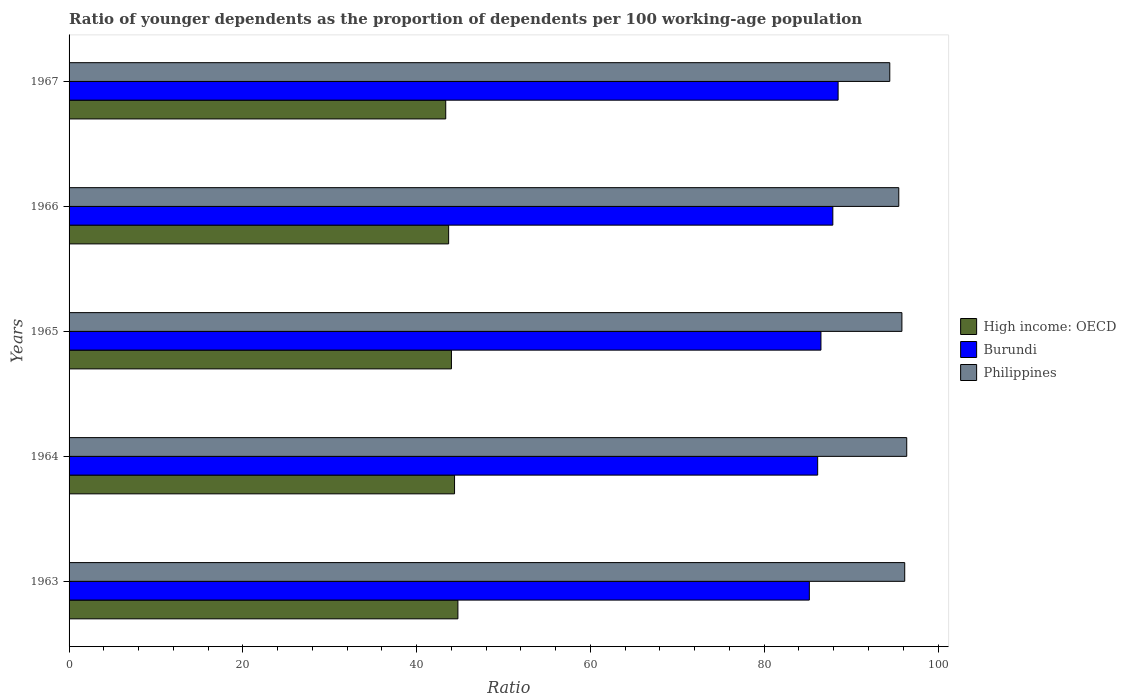Are the number of bars per tick equal to the number of legend labels?
Ensure brevity in your answer.  Yes. Are the number of bars on each tick of the Y-axis equal?
Ensure brevity in your answer.  Yes. How many bars are there on the 3rd tick from the top?
Your answer should be compact. 3. How many bars are there on the 2nd tick from the bottom?
Offer a very short reply. 3. In how many cases, is the number of bars for a given year not equal to the number of legend labels?
Your response must be concise. 0. What is the age dependency ratio(young) in Philippines in 1963?
Provide a succinct answer. 96.17. Across all years, what is the maximum age dependency ratio(young) in Philippines?
Your answer should be very brief. 96.4. Across all years, what is the minimum age dependency ratio(young) in High income: OECD?
Your answer should be compact. 43.35. In which year was the age dependency ratio(young) in Philippines minimum?
Your answer should be compact. 1967. What is the total age dependency ratio(young) in High income: OECD in the graph?
Ensure brevity in your answer.  220.14. What is the difference between the age dependency ratio(young) in Burundi in 1963 and that in 1965?
Make the answer very short. -1.34. What is the difference between the age dependency ratio(young) in High income: OECD in 1967 and the age dependency ratio(young) in Burundi in 1963?
Your response must be concise. -41.84. What is the average age dependency ratio(young) in Philippines per year?
Your answer should be compact. 95.67. In the year 1967, what is the difference between the age dependency ratio(young) in High income: OECD and age dependency ratio(young) in Philippines?
Make the answer very short. -51.1. In how many years, is the age dependency ratio(young) in High income: OECD greater than 60 ?
Your answer should be compact. 0. What is the ratio of the age dependency ratio(young) in Burundi in 1965 to that in 1967?
Offer a very short reply. 0.98. Is the age dependency ratio(young) in High income: OECD in 1965 less than that in 1967?
Keep it short and to the point. No. What is the difference between the highest and the second highest age dependency ratio(young) in High income: OECD?
Offer a terse response. 0.39. What is the difference between the highest and the lowest age dependency ratio(young) in High income: OECD?
Offer a very short reply. 1.4. What does the 3rd bar from the top in 1963 represents?
Provide a short and direct response. High income: OECD. What does the 3rd bar from the bottom in 1965 represents?
Offer a terse response. Philippines. What is the difference between two consecutive major ticks on the X-axis?
Provide a short and direct response. 20. Does the graph contain any zero values?
Provide a short and direct response. No. How many legend labels are there?
Your answer should be very brief. 3. What is the title of the graph?
Provide a short and direct response. Ratio of younger dependents as the proportion of dependents per 100 working-age population. Does "Cabo Verde" appear as one of the legend labels in the graph?
Provide a short and direct response. No. What is the label or title of the X-axis?
Your response must be concise. Ratio. What is the Ratio of High income: OECD in 1963?
Provide a succinct answer. 44.75. What is the Ratio in Burundi in 1963?
Provide a succinct answer. 85.19. What is the Ratio in Philippines in 1963?
Provide a short and direct response. 96.17. What is the Ratio in High income: OECD in 1964?
Make the answer very short. 44.36. What is the Ratio in Burundi in 1964?
Ensure brevity in your answer.  86.15. What is the Ratio of Philippines in 1964?
Ensure brevity in your answer.  96.4. What is the Ratio of High income: OECD in 1965?
Offer a terse response. 44. What is the Ratio of Burundi in 1965?
Your response must be concise. 86.53. What is the Ratio of Philippines in 1965?
Your answer should be compact. 95.85. What is the Ratio of High income: OECD in 1966?
Provide a short and direct response. 43.68. What is the Ratio of Burundi in 1966?
Provide a succinct answer. 87.9. What is the Ratio of Philippines in 1966?
Give a very brief answer. 95.49. What is the Ratio of High income: OECD in 1967?
Give a very brief answer. 43.35. What is the Ratio in Burundi in 1967?
Offer a terse response. 88.5. What is the Ratio of Philippines in 1967?
Offer a terse response. 94.45. Across all years, what is the maximum Ratio of High income: OECD?
Your answer should be very brief. 44.75. Across all years, what is the maximum Ratio of Burundi?
Give a very brief answer. 88.5. Across all years, what is the maximum Ratio of Philippines?
Offer a very short reply. 96.4. Across all years, what is the minimum Ratio in High income: OECD?
Provide a succinct answer. 43.35. Across all years, what is the minimum Ratio in Burundi?
Your response must be concise. 85.19. Across all years, what is the minimum Ratio in Philippines?
Offer a very short reply. 94.45. What is the total Ratio in High income: OECD in the graph?
Give a very brief answer. 220.14. What is the total Ratio of Burundi in the graph?
Your answer should be compact. 434.28. What is the total Ratio in Philippines in the graph?
Offer a very short reply. 478.36. What is the difference between the Ratio in High income: OECD in 1963 and that in 1964?
Your answer should be compact. 0.39. What is the difference between the Ratio of Burundi in 1963 and that in 1964?
Your answer should be compact. -0.96. What is the difference between the Ratio in Philippines in 1963 and that in 1964?
Ensure brevity in your answer.  -0.23. What is the difference between the Ratio in High income: OECD in 1963 and that in 1965?
Give a very brief answer. 0.74. What is the difference between the Ratio of Burundi in 1963 and that in 1965?
Provide a succinct answer. -1.34. What is the difference between the Ratio of Philippines in 1963 and that in 1965?
Provide a short and direct response. 0.32. What is the difference between the Ratio of High income: OECD in 1963 and that in 1966?
Your response must be concise. 1.07. What is the difference between the Ratio in Burundi in 1963 and that in 1966?
Your response must be concise. -2.7. What is the difference between the Ratio of Philippines in 1963 and that in 1966?
Give a very brief answer. 0.68. What is the difference between the Ratio in High income: OECD in 1963 and that in 1967?
Offer a terse response. 1.4. What is the difference between the Ratio in Burundi in 1963 and that in 1967?
Provide a short and direct response. -3.31. What is the difference between the Ratio of Philippines in 1963 and that in 1967?
Your answer should be compact. 1.72. What is the difference between the Ratio in High income: OECD in 1964 and that in 1965?
Your answer should be compact. 0.36. What is the difference between the Ratio of Burundi in 1964 and that in 1965?
Provide a succinct answer. -0.38. What is the difference between the Ratio of Philippines in 1964 and that in 1965?
Offer a terse response. 0.56. What is the difference between the Ratio of High income: OECD in 1964 and that in 1966?
Provide a short and direct response. 0.68. What is the difference between the Ratio in Burundi in 1964 and that in 1966?
Your response must be concise. -1.74. What is the difference between the Ratio of Philippines in 1964 and that in 1966?
Offer a very short reply. 0.91. What is the difference between the Ratio in High income: OECD in 1964 and that in 1967?
Keep it short and to the point. 1.01. What is the difference between the Ratio in Burundi in 1964 and that in 1967?
Offer a very short reply. -2.35. What is the difference between the Ratio in Philippines in 1964 and that in 1967?
Offer a very short reply. 1.95. What is the difference between the Ratio of High income: OECD in 1965 and that in 1966?
Your answer should be very brief. 0.32. What is the difference between the Ratio of Burundi in 1965 and that in 1966?
Your answer should be very brief. -1.37. What is the difference between the Ratio of Philippines in 1965 and that in 1966?
Your response must be concise. 0.36. What is the difference between the Ratio in High income: OECD in 1965 and that in 1967?
Provide a succinct answer. 0.65. What is the difference between the Ratio in Burundi in 1965 and that in 1967?
Offer a very short reply. -1.97. What is the difference between the Ratio of Philippines in 1965 and that in 1967?
Provide a short and direct response. 1.4. What is the difference between the Ratio of High income: OECD in 1966 and that in 1967?
Your response must be concise. 0.33. What is the difference between the Ratio of Burundi in 1966 and that in 1967?
Give a very brief answer. -0.61. What is the difference between the Ratio in High income: OECD in 1963 and the Ratio in Burundi in 1964?
Ensure brevity in your answer.  -41.4. What is the difference between the Ratio of High income: OECD in 1963 and the Ratio of Philippines in 1964?
Ensure brevity in your answer.  -51.65. What is the difference between the Ratio in Burundi in 1963 and the Ratio in Philippines in 1964?
Provide a short and direct response. -11.21. What is the difference between the Ratio in High income: OECD in 1963 and the Ratio in Burundi in 1965?
Provide a succinct answer. -41.78. What is the difference between the Ratio of High income: OECD in 1963 and the Ratio of Philippines in 1965?
Ensure brevity in your answer.  -51.1. What is the difference between the Ratio of Burundi in 1963 and the Ratio of Philippines in 1965?
Ensure brevity in your answer.  -10.65. What is the difference between the Ratio in High income: OECD in 1963 and the Ratio in Burundi in 1966?
Offer a terse response. -43.15. What is the difference between the Ratio in High income: OECD in 1963 and the Ratio in Philippines in 1966?
Keep it short and to the point. -50.74. What is the difference between the Ratio of Burundi in 1963 and the Ratio of Philippines in 1966?
Provide a succinct answer. -10.29. What is the difference between the Ratio in High income: OECD in 1963 and the Ratio in Burundi in 1967?
Keep it short and to the point. -43.76. What is the difference between the Ratio of High income: OECD in 1963 and the Ratio of Philippines in 1967?
Offer a terse response. -49.7. What is the difference between the Ratio of Burundi in 1963 and the Ratio of Philippines in 1967?
Make the answer very short. -9.26. What is the difference between the Ratio in High income: OECD in 1964 and the Ratio in Burundi in 1965?
Give a very brief answer. -42.17. What is the difference between the Ratio of High income: OECD in 1964 and the Ratio of Philippines in 1965?
Provide a short and direct response. -51.48. What is the difference between the Ratio of Burundi in 1964 and the Ratio of Philippines in 1965?
Offer a very short reply. -9.69. What is the difference between the Ratio of High income: OECD in 1964 and the Ratio of Burundi in 1966?
Provide a succinct answer. -43.53. What is the difference between the Ratio in High income: OECD in 1964 and the Ratio in Philippines in 1966?
Make the answer very short. -51.13. What is the difference between the Ratio of Burundi in 1964 and the Ratio of Philippines in 1966?
Your answer should be compact. -9.33. What is the difference between the Ratio of High income: OECD in 1964 and the Ratio of Burundi in 1967?
Your response must be concise. -44.14. What is the difference between the Ratio of High income: OECD in 1964 and the Ratio of Philippines in 1967?
Your answer should be compact. -50.09. What is the difference between the Ratio in Burundi in 1964 and the Ratio in Philippines in 1967?
Offer a very short reply. -8.3. What is the difference between the Ratio in High income: OECD in 1965 and the Ratio in Burundi in 1966?
Make the answer very short. -43.89. What is the difference between the Ratio of High income: OECD in 1965 and the Ratio of Philippines in 1966?
Give a very brief answer. -51.48. What is the difference between the Ratio in Burundi in 1965 and the Ratio in Philippines in 1966?
Your answer should be very brief. -8.96. What is the difference between the Ratio of High income: OECD in 1965 and the Ratio of Burundi in 1967?
Give a very brief answer. -44.5. What is the difference between the Ratio in High income: OECD in 1965 and the Ratio in Philippines in 1967?
Provide a succinct answer. -50.45. What is the difference between the Ratio in Burundi in 1965 and the Ratio in Philippines in 1967?
Ensure brevity in your answer.  -7.92. What is the difference between the Ratio in High income: OECD in 1966 and the Ratio in Burundi in 1967?
Ensure brevity in your answer.  -44.82. What is the difference between the Ratio in High income: OECD in 1966 and the Ratio in Philippines in 1967?
Offer a very short reply. -50.77. What is the difference between the Ratio of Burundi in 1966 and the Ratio of Philippines in 1967?
Your answer should be very brief. -6.55. What is the average Ratio of High income: OECD per year?
Provide a short and direct response. 44.03. What is the average Ratio of Burundi per year?
Provide a succinct answer. 86.86. What is the average Ratio of Philippines per year?
Ensure brevity in your answer.  95.67. In the year 1963, what is the difference between the Ratio in High income: OECD and Ratio in Burundi?
Provide a short and direct response. -40.44. In the year 1963, what is the difference between the Ratio in High income: OECD and Ratio in Philippines?
Provide a succinct answer. -51.42. In the year 1963, what is the difference between the Ratio in Burundi and Ratio in Philippines?
Give a very brief answer. -10.98. In the year 1964, what is the difference between the Ratio of High income: OECD and Ratio of Burundi?
Your response must be concise. -41.79. In the year 1964, what is the difference between the Ratio of High income: OECD and Ratio of Philippines?
Offer a very short reply. -52.04. In the year 1964, what is the difference between the Ratio of Burundi and Ratio of Philippines?
Provide a short and direct response. -10.25. In the year 1965, what is the difference between the Ratio of High income: OECD and Ratio of Burundi?
Provide a short and direct response. -42.53. In the year 1965, what is the difference between the Ratio of High income: OECD and Ratio of Philippines?
Your response must be concise. -51.84. In the year 1965, what is the difference between the Ratio of Burundi and Ratio of Philippines?
Ensure brevity in your answer.  -9.32. In the year 1966, what is the difference between the Ratio in High income: OECD and Ratio in Burundi?
Provide a short and direct response. -44.21. In the year 1966, what is the difference between the Ratio in High income: OECD and Ratio in Philippines?
Keep it short and to the point. -51.8. In the year 1966, what is the difference between the Ratio in Burundi and Ratio in Philippines?
Ensure brevity in your answer.  -7.59. In the year 1967, what is the difference between the Ratio in High income: OECD and Ratio in Burundi?
Your answer should be very brief. -45.16. In the year 1967, what is the difference between the Ratio in High income: OECD and Ratio in Philippines?
Offer a terse response. -51.1. In the year 1967, what is the difference between the Ratio of Burundi and Ratio of Philippines?
Your answer should be compact. -5.95. What is the ratio of the Ratio in High income: OECD in 1963 to that in 1964?
Make the answer very short. 1.01. What is the ratio of the Ratio of Burundi in 1963 to that in 1964?
Your answer should be very brief. 0.99. What is the ratio of the Ratio of High income: OECD in 1963 to that in 1965?
Ensure brevity in your answer.  1.02. What is the ratio of the Ratio in Burundi in 1963 to that in 1965?
Your answer should be very brief. 0.98. What is the ratio of the Ratio in High income: OECD in 1963 to that in 1966?
Provide a short and direct response. 1.02. What is the ratio of the Ratio in Burundi in 1963 to that in 1966?
Provide a succinct answer. 0.97. What is the ratio of the Ratio of High income: OECD in 1963 to that in 1967?
Provide a succinct answer. 1.03. What is the ratio of the Ratio of Burundi in 1963 to that in 1967?
Offer a terse response. 0.96. What is the ratio of the Ratio of Philippines in 1963 to that in 1967?
Your answer should be compact. 1.02. What is the ratio of the Ratio in High income: OECD in 1964 to that in 1965?
Offer a very short reply. 1.01. What is the ratio of the Ratio of Burundi in 1964 to that in 1965?
Provide a short and direct response. 1. What is the ratio of the Ratio in Philippines in 1964 to that in 1965?
Give a very brief answer. 1.01. What is the ratio of the Ratio of High income: OECD in 1964 to that in 1966?
Give a very brief answer. 1.02. What is the ratio of the Ratio of Burundi in 1964 to that in 1966?
Your answer should be compact. 0.98. What is the ratio of the Ratio of Philippines in 1964 to that in 1966?
Make the answer very short. 1.01. What is the ratio of the Ratio in High income: OECD in 1964 to that in 1967?
Provide a succinct answer. 1.02. What is the ratio of the Ratio in Burundi in 1964 to that in 1967?
Provide a short and direct response. 0.97. What is the ratio of the Ratio of Philippines in 1964 to that in 1967?
Keep it short and to the point. 1.02. What is the ratio of the Ratio in High income: OECD in 1965 to that in 1966?
Provide a short and direct response. 1.01. What is the ratio of the Ratio in Burundi in 1965 to that in 1966?
Keep it short and to the point. 0.98. What is the ratio of the Ratio in Philippines in 1965 to that in 1966?
Make the answer very short. 1. What is the ratio of the Ratio of High income: OECD in 1965 to that in 1967?
Your answer should be compact. 1.02. What is the ratio of the Ratio of Burundi in 1965 to that in 1967?
Your answer should be very brief. 0.98. What is the ratio of the Ratio of Philippines in 1965 to that in 1967?
Keep it short and to the point. 1.01. What is the ratio of the Ratio of High income: OECD in 1966 to that in 1967?
Offer a very short reply. 1.01. What is the difference between the highest and the second highest Ratio in High income: OECD?
Your answer should be very brief. 0.39. What is the difference between the highest and the second highest Ratio in Burundi?
Provide a short and direct response. 0.61. What is the difference between the highest and the second highest Ratio in Philippines?
Offer a very short reply. 0.23. What is the difference between the highest and the lowest Ratio of High income: OECD?
Make the answer very short. 1.4. What is the difference between the highest and the lowest Ratio of Burundi?
Keep it short and to the point. 3.31. What is the difference between the highest and the lowest Ratio of Philippines?
Give a very brief answer. 1.95. 